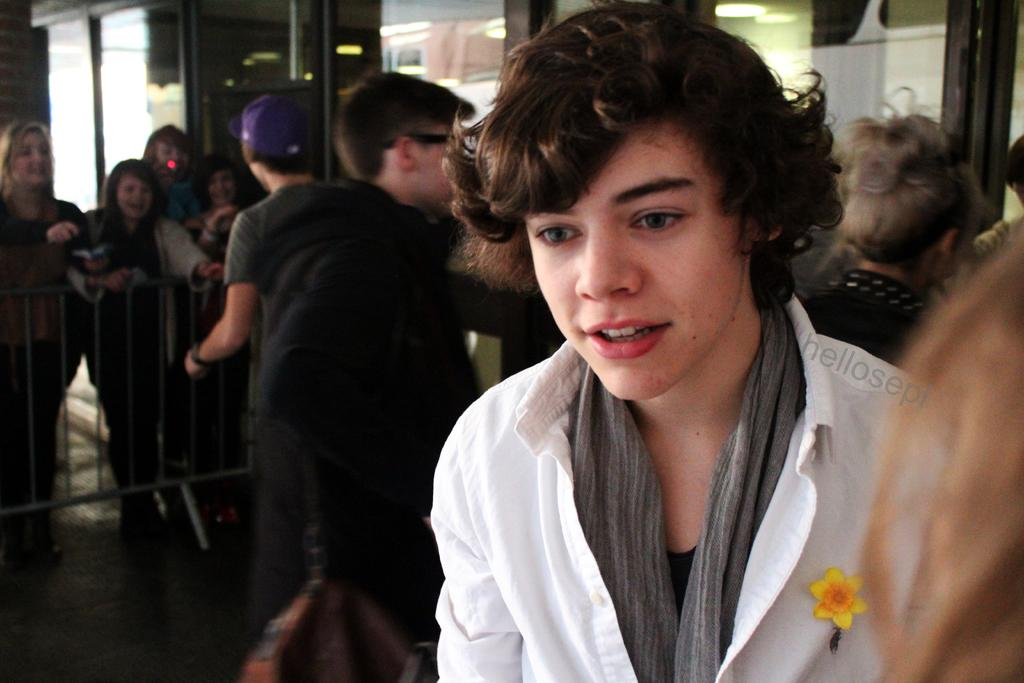What types of individuals are present in the image? There are people in the image, including men and women. Can you describe the background of the image? The background of the image is blurred. What type of cheese can be seen on the corn in the image? There is no cheese or corn present in the image; it features people with a blurred background. 